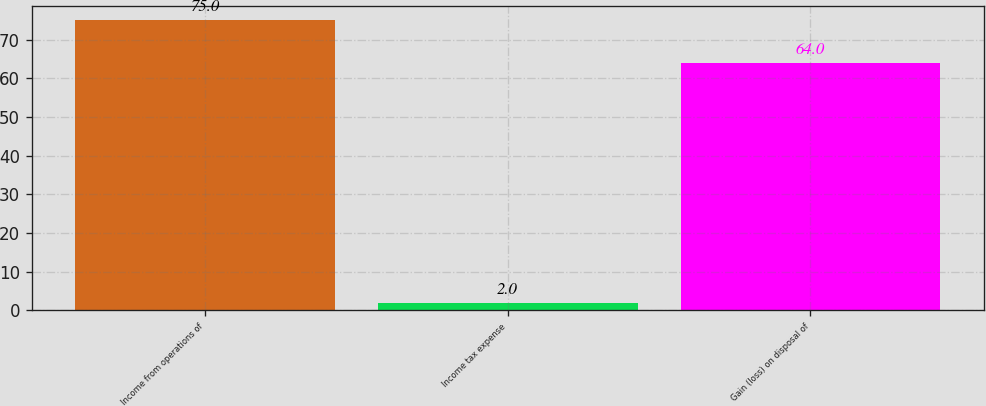Convert chart to OTSL. <chart><loc_0><loc_0><loc_500><loc_500><bar_chart><fcel>Income from operations of<fcel>Income tax expense<fcel>Gain (loss) on disposal of<nl><fcel>75<fcel>2<fcel>64<nl></chart> 